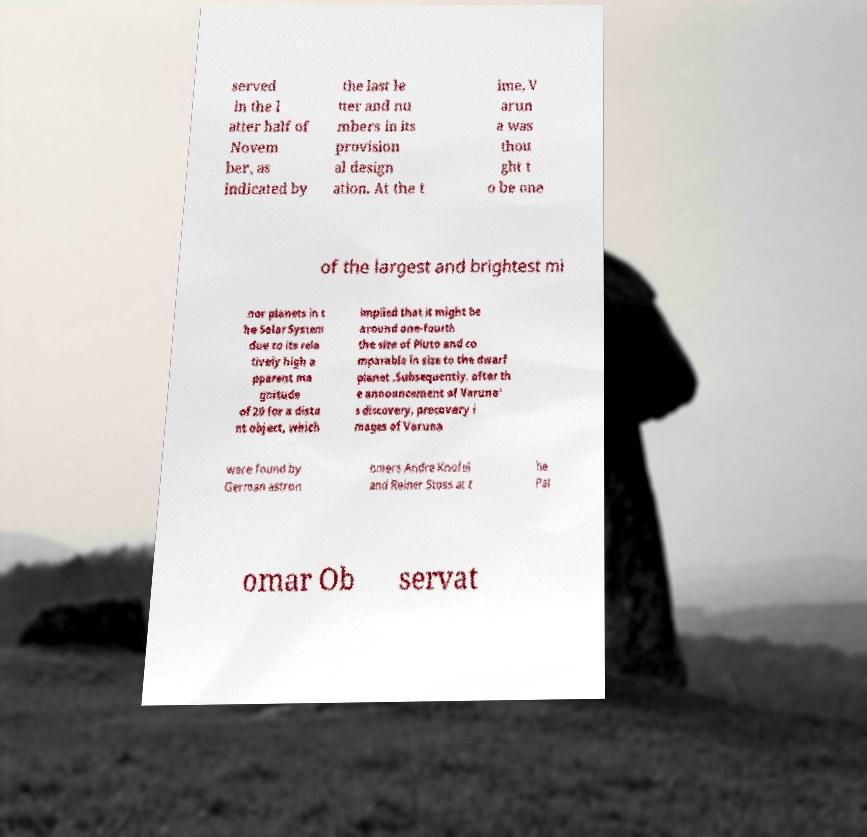For documentation purposes, I need the text within this image transcribed. Could you provide that? served in the l atter half of Novem ber, as indicated by the last le tter and nu mbers in its provision al design ation. At the t ime, V arun a was thou ght t o be one of the largest and brightest mi nor planets in t he Solar System due to its rela tively high a pparent ma gnitude of 20 for a dista nt object, which implied that it might be around one-fourth the size of Pluto and co mparable in size to the dwarf planet .Subsequently, after th e announcement of Varuna' s discovery, precovery i mages of Varuna were found by German astron omers Andre Knofel and Reiner Stoss at t he Pal omar Ob servat 